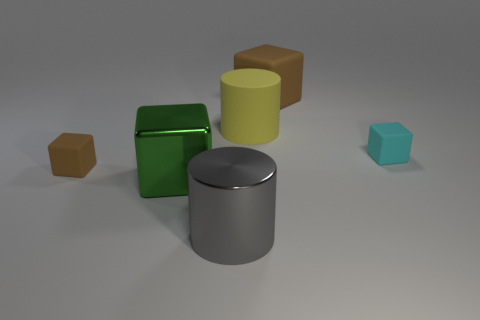Add 2 red objects. How many objects exist? 8 Subtract all large brown blocks. How many blocks are left? 3 Subtract all yellow cylinders. How many brown cubes are left? 2 Subtract all cylinders. How many objects are left? 4 Subtract all small gray blocks. Subtract all gray objects. How many objects are left? 5 Add 1 big green cubes. How many big green cubes are left? 2 Add 1 small brown blocks. How many small brown blocks exist? 2 Subtract all green blocks. How many blocks are left? 3 Subtract 1 green blocks. How many objects are left? 5 Subtract 2 blocks. How many blocks are left? 2 